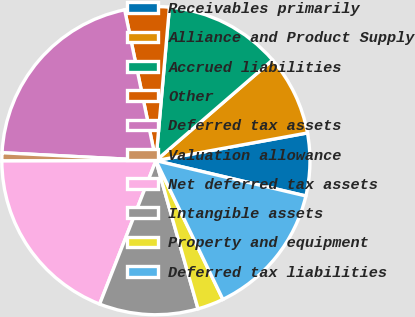<chart> <loc_0><loc_0><loc_500><loc_500><pie_chart><fcel>Receivables primarily<fcel>Alliance and Product Supply<fcel>Accrued liabilities<fcel>Other<fcel>Deferred tax assets<fcel>Valuation allowance<fcel>Net deferred tax assets<fcel>Intangible assets<fcel>Property and equipment<fcel>Deferred tax liabilities<nl><fcel>6.56%<fcel>8.46%<fcel>12.26%<fcel>4.65%<fcel>20.93%<fcel>0.85%<fcel>19.02%<fcel>10.36%<fcel>2.75%<fcel>14.16%<nl></chart> 